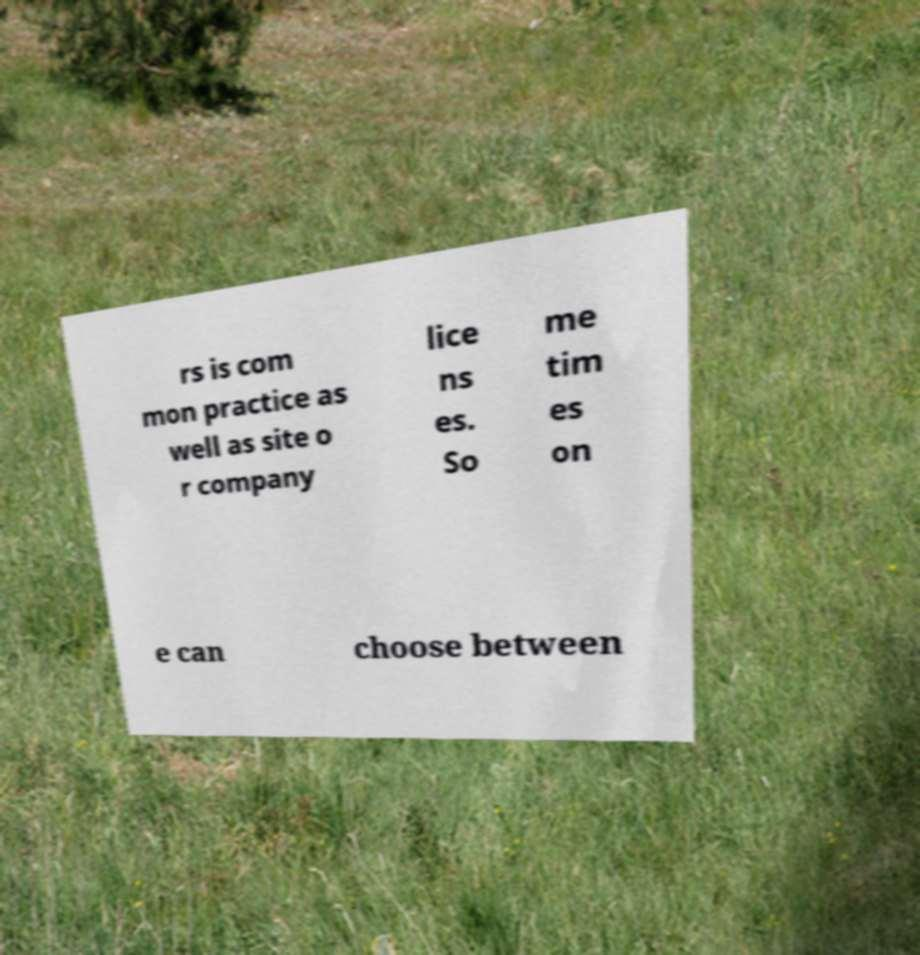Could you extract and type out the text from this image? rs is com mon practice as well as site o r company lice ns es. So me tim es on e can choose between 